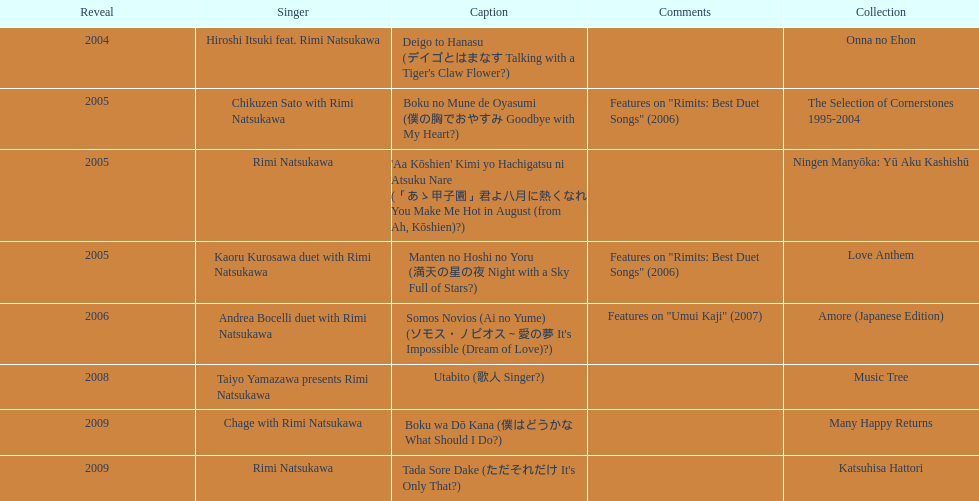What song was this artist on after utabito? Boku wa Dō Kana. 